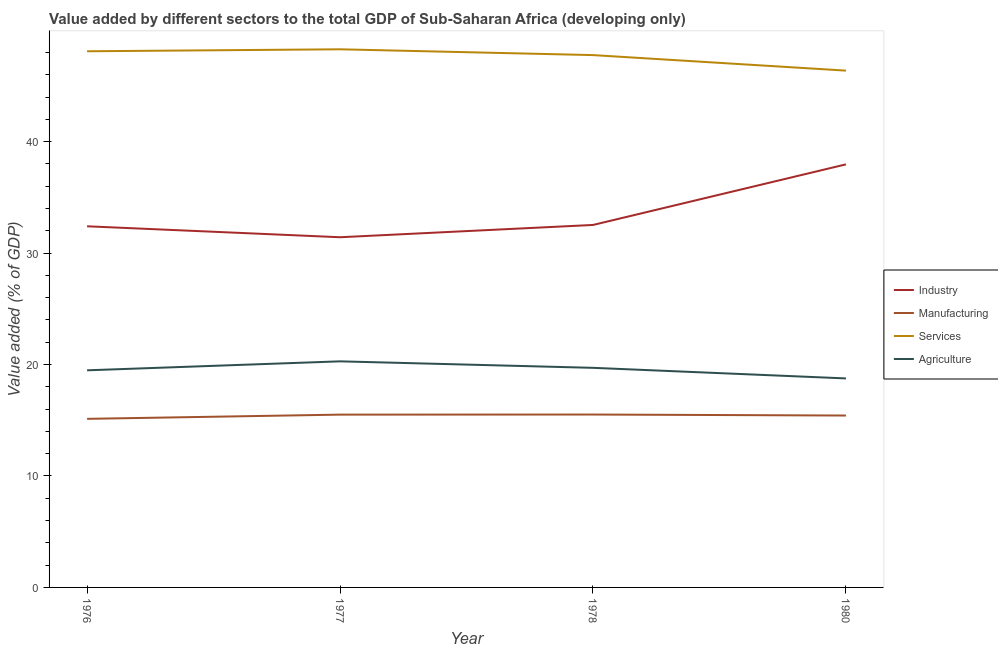How many different coloured lines are there?
Keep it short and to the point. 4. Is the number of lines equal to the number of legend labels?
Provide a succinct answer. Yes. What is the value added by industrial sector in 1980?
Keep it short and to the point. 37.96. Across all years, what is the maximum value added by agricultural sector?
Your response must be concise. 20.29. Across all years, what is the minimum value added by manufacturing sector?
Your answer should be compact. 15.13. In which year was the value added by services sector minimum?
Your answer should be very brief. 1980. What is the total value added by industrial sector in the graph?
Provide a short and direct response. 134.32. What is the difference between the value added by agricultural sector in 1976 and that in 1980?
Your response must be concise. 0.73. What is the difference between the value added by industrial sector in 1980 and the value added by agricultural sector in 1976?
Your answer should be compact. 18.48. What is the average value added by services sector per year?
Offer a terse response. 47.64. In the year 1980, what is the difference between the value added by services sector and value added by agricultural sector?
Give a very brief answer. 27.62. What is the ratio of the value added by agricultural sector in 1976 to that in 1977?
Make the answer very short. 0.96. Is the value added by agricultural sector in 1977 less than that in 1978?
Make the answer very short. No. What is the difference between the highest and the second highest value added by services sector?
Offer a very short reply. 0.18. What is the difference between the highest and the lowest value added by agricultural sector?
Offer a terse response. 1.53. Is it the case that in every year, the sum of the value added by services sector and value added by agricultural sector is greater than the sum of value added by industrial sector and value added by manufacturing sector?
Provide a short and direct response. Yes. Does the value added by agricultural sector monotonically increase over the years?
Keep it short and to the point. No. Is the value added by services sector strictly less than the value added by manufacturing sector over the years?
Your answer should be very brief. No. How many years are there in the graph?
Provide a succinct answer. 4. Are the values on the major ticks of Y-axis written in scientific E-notation?
Give a very brief answer. No. How many legend labels are there?
Ensure brevity in your answer.  4. How are the legend labels stacked?
Your answer should be very brief. Vertical. What is the title of the graph?
Keep it short and to the point. Value added by different sectors to the total GDP of Sub-Saharan Africa (developing only). What is the label or title of the X-axis?
Your answer should be compact. Year. What is the label or title of the Y-axis?
Provide a succinct answer. Value added (% of GDP). What is the Value added (% of GDP) in Industry in 1976?
Make the answer very short. 32.41. What is the Value added (% of GDP) in Manufacturing in 1976?
Make the answer very short. 15.13. What is the Value added (% of GDP) in Services in 1976?
Your response must be concise. 48.11. What is the Value added (% of GDP) of Agriculture in 1976?
Your response must be concise. 19.48. What is the Value added (% of GDP) of Industry in 1977?
Offer a terse response. 31.42. What is the Value added (% of GDP) of Manufacturing in 1977?
Give a very brief answer. 15.51. What is the Value added (% of GDP) in Services in 1977?
Give a very brief answer. 48.29. What is the Value added (% of GDP) in Agriculture in 1977?
Ensure brevity in your answer.  20.29. What is the Value added (% of GDP) in Industry in 1978?
Your answer should be very brief. 32.53. What is the Value added (% of GDP) of Manufacturing in 1978?
Make the answer very short. 15.51. What is the Value added (% of GDP) of Services in 1978?
Ensure brevity in your answer.  47.77. What is the Value added (% of GDP) of Agriculture in 1978?
Offer a terse response. 19.71. What is the Value added (% of GDP) of Industry in 1980?
Give a very brief answer. 37.96. What is the Value added (% of GDP) in Manufacturing in 1980?
Make the answer very short. 15.42. What is the Value added (% of GDP) in Services in 1980?
Make the answer very short. 46.38. What is the Value added (% of GDP) in Agriculture in 1980?
Your answer should be compact. 18.75. Across all years, what is the maximum Value added (% of GDP) in Industry?
Your response must be concise. 37.96. Across all years, what is the maximum Value added (% of GDP) in Manufacturing?
Give a very brief answer. 15.51. Across all years, what is the maximum Value added (% of GDP) of Services?
Keep it short and to the point. 48.29. Across all years, what is the maximum Value added (% of GDP) in Agriculture?
Make the answer very short. 20.29. Across all years, what is the minimum Value added (% of GDP) in Industry?
Offer a terse response. 31.42. Across all years, what is the minimum Value added (% of GDP) of Manufacturing?
Keep it short and to the point. 15.13. Across all years, what is the minimum Value added (% of GDP) of Services?
Offer a very short reply. 46.38. Across all years, what is the minimum Value added (% of GDP) of Agriculture?
Provide a short and direct response. 18.75. What is the total Value added (% of GDP) in Industry in the graph?
Provide a short and direct response. 134.32. What is the total Value added (% of GDP) of Manufacturing in the graph?
Give a very brief answer. 61.57. What is the total Value added (% of GDP) in Services in the graph?
Provide a short and direct response. 190.54. What is the total Value added (% of GDP) of Agriculture in the graph?
Keep it short and to the point. 78.23. What is the difference between the Value added (% of GDP) in Industry in 1976 and that in 1977?
Make the answer very short. 0.98. What is the difference between the Value added (% of GDP) of Manufacturing in 1976 and that in 1977?
Give a very brief answer. -0.38. What is the difference between the Value added (% of GDP) of Services in 1976 and that in 1977?
Ensure brevity in your answer.  -0.18. What is the difference between the Value added (% of GDP) of Agriculture in 1976 and that in 1977?
Offer a terse response. -0.81. What is the difference between the Value added (% of GDP) in Industry in 1976 and that in 1978?
Keep it short and to the point. -0.12. What is the difference between the Value added (% of GDP) of Manufacturing in 1976 and that in 1978?
Provide a short and direct response. -0.39. What is the difference between the Value added (% of GDP) in Services in 1976 and that in 1978?
Give a very brief answer. 0.34. What is the difference between the Value added (% of GDP) in Agriculture in 1976 and that in 1978?
Your answer should be very brief. -0.22. What is the difference between the Value added (% of GDP) of Industry in 1976 and that in 1980?
Your answer should be very brief. -5.56. What is the difference between the Value added (% of GDP) in Manufacturing in 1976 and that in 1980?
Keep it short and to the point. -0.3. What is the difference between the Value added (% of GDP) in Services in 1976 and that in 1980?
Provide a short and direct response. 1.74. What is the difference between the Value added (% of GDP) in Agriculture in 1976 and that in 1980?
Offer a terse response. 0.73. What is the difference between the Value added (% of GDP) in Industry in 1977 and that in 1978?
Make the answer very short. -1.1. What is the difference between the Value added (% of GDP) of Manufacturing in 1977 and that in 1978?
Give a very brief answer. -0.01. What is the difference between the Value added (% of GDP) in Services in 1977 and that in 1978?
Give a very brief answer. 0.52. What is the difference between the Value added (% of GDP) in Agriculture in 1977 and that in 1978?
Provide a short and direct response. 0.58. What is the difference between the Value added (% of GDP) of Industry in 1977 and that in 1980?
Your answer should be very brief. -6.54. What is the difference between the Value added (% of GDP) in Manufacturing in 1977 and that in 1980?
Your response must be concise. 0.08. What is the difference between the Value added (% of GDP) of Services in 1977 and that in 1980?
Your answer should be compact. 1.91. What is the difference between the Value added (% of GDP) in Agriculture in 1977 and that in 1980?
Provide a short and direct response. 1.53. What is the difference between the Value added (% of GDP) of Industry in 1978 and that in 1980?
Ensure brevity in your answer.  -5.44. What is the difference between the Value added (% of GDP) in Manufacturing in 1978 and that in 1980?
Ensure brevity in your answer.  0.09. What is the difference between the Value added (% of GDP) of Services in 1978 and that in 1980?
Keep it short and to the point. 1.39. What is the difference between the Value added (% of GDP) of Agriculture in 1978 and that in 1980?
Your response must be concise. 0.95. What is the difference between the Value added (% of GDP) in Industry in 1976 and the Value added (% of GDP) in Manufacturing in 1977?
Offer a very short reply. 16.9. What is the difference between the Value added (% of GDP) in Industry in 1976 and the Value added (% of GDP) in Services in 1977?
Make the answer very short. -15.88. What is the difference between the Value added (% of GDP) in Industry in 1976 and the Value added (% of GDP) in Agriculture in 1977?
Ensure brevity in your answer.  12.12. What is the difference between the Value added (% of GDP) in Manufacturing in 1976 and the Value added (% of GDP) in Services in 1977?
Keep it short and to the point. -33.16. What is the difference between the Value added (% of GDP) of Manufacturing in 1976 and the Value added (% of GDP) of Agriculture in 1977?
Your response must be concise. -5.16. What is the difference between the Value added (% of GDP) of Services in 1976 and the Value added (% of GDP) of Agriculture in 1977?
Your response must be concise. 27.82. What is the difference between the Value added (% of GDP) in Industry in 1976 and the Value added (% of GDP) in Manufacturing in 1978?
Make the answer very short. 16.89. What is the difference between the Value added (% of GDP) of Industry in 1976 and the Value added (% of GDP) of Services in 1978?
Your answer should be compact. -15.36. What is the difference between the Value added (% of GDP) of Industry in 1976 and the Value added (% of GDP) of Agriculture in 1978?
Your answer should be very brief. 12.7. What is the difference between the Value added (% of GDP) of Manufacturing in 1976 and the Value added (% of GDP) of Services in 1978?
Your response must be concise. -32.64. What is the difference between the Value added (% of GDP) in Manufacturing in 1976 and the Value added (% of GDP) in Agriculture in 1978?
Make the answer very short. -4.58. What is the difference between the Value added (% of GDP) in Services in 1976 and the Value added (% of GDP) in Agriculture in 1978?
Provide a succinct answer. 28.41. What is the difference between the Value added (% of GDP) of Industry in 1976 and the Value added (% of GDP) of Manufacturing in 1980?
Offer a very short reply. 16.98. What is the difference between the Value added (% of GDP) in Industry in 1976 and the Value added (% of GDP) in Services in 1980?
Your response must be concise. -13.97. What is the difference between the Value added (% of GDP) in Industry in 1976 and the Value added (% of GDP) in Agriculture in 1980?
Your response must be concise. 13.65. What is the difference between the Value added (% of GDP) of Manufacturing in 1976 and the Value added (% of GDP) of Services in 1980?
Keep it short and to the point. -31.25. What is the difference between the Value added (% of GDP) of Manufacturing in 1976 and the Value added (% of GDP) of Agriculture in 1980?
Make the answer very short. -3.63. What is the difference between the Value added (% of GDP) in Services in 1976 and the Value added (% of GDP) in Agriculture in 1980?
Provide a succinct answer. 29.36. What is the difference between the Value added (% of GDP) of Industry in 1977 and the Value added (% of GDP) of Manufacturing in 1978?
Provide a succinct answer. 15.91. What is the difference between the Value added (% of GDP) in Industry in 1977 and the Value added (% of GDP) in Services in 1978?
Your answer should be compact. -16.35. What is the difference between the Value added (% of GDP) of Industry in 1977 and the Value added (% of GDP) of Agriculture in 1978?
Ensure brevity in your answer.  11.72. What is the difference between the Value added (% of GDP) in Manufacturing in 1977 and the Value added (% of GDP) in Services in 1978?
Offer a terse response. -32.26. What is the difference between the Value added (% of GDP) of Manufacturing in 1977 and the Value added (% of GDP) of Agriculture in 1978?
Ensure brevity in your answer.  -4.2. What is the difference between the Value added (% of GDP) in Services in 1977 and the Value added (% of GDP) in Agriculture in 1978?
Your response must be concise. 28.58. What is the difference between the Value added (% of GDP) of Industry in 1977 and the Value added (% of GDP) of Manufacturing in 1980?
Offer a terse response. 16. What is the difference between the Value added (% of GDP) of Industry in 1977 and the Value added (% of GDP) of Services in 1980?
Keep it short and to the point. -14.95. What is the difference between the Value added (% of GDP) of Industry in 1977 and the Value added (% of GDP) of Agriculture in 1980?
Make the answer very short. 12.67. What is the difference between the Value added (% of GDP) in Manufacturing in 1977 and the Value added (% of GDP) in Services in 1980?
Your answer should be compact. -30.87. What is the difference between the Value added (% of GDP) in Manufacturing in 1977 and the Value added (% of GDP) in Agriculture in 1980?
Keep it short and to the point. -3.25. What is the difference between the Value added (% of GDP) in Services in 1977 and the Value added (% of GDP) in Agriculture in 1980?
Provide a succinct answer. 29.53. What is the difference between the Value added (% of GDP) in Industry in 1978 and the Value added (% of GDP) in Manufacturing in 1980?
Make the answer very short. 17.1. What is the difference between the Value added (% of GDP) in Industry in 1978 and the Value added (% of GDP) in Services in 1980?
Ensure brevity in your answer.  -13.85. What is the difference between the Value added (% of GDP) in Industry in 1978 and the Value added (% of GDP) in Agriculture in 1980?
Your answer should be very brief. 13.77. What is the difference between the Value added (% of GDP) of Manufacturing in 1978 and the Value added (% of GDP) of Services in 1980?
Give a very brief answer. -30.86. What is the difference between the Value added (% of GDP) of Manufacturing in 1978 and the Value added (% of GDP) of Agriculture in 1980?
Offer a terse response. -3.24. What is the difference between the Value added (% of GDP) in Services in 1978 and the Value added (% of GDP) in Agriculture in 1980?
Your response must be concise. 29.01. What is the average Value added (% of GDP) in Industry per year?
Your answer should be compact. 33.58. What is the average Value added (% of GDP) of Manufacturing per year?
Provide a short and direct response. 15.39. What is the average Value added (% of GDP) of Services per year?
Give a very brief answer. 47.64. What is the average Value added (% of GDP) of Agriculture per year?
Provide a short and direct response. 19.56. In the year 1976, what is the difference between the Value added (% of GDP) of Industry and Value added (% of GDP) of Manufacturing?
Your answer should be compact. 17.28. In the year 1976, what is the difference between the Value added (% of GDP) in Industry and Value added (% of GDP) in Services?
Keep it short and to the point. -15.71. In the year 1976, what is the difference between the Value added (% of GDP) of Industry and Value added (% of GDP) of Agriculture?
Keep it short and to the point. 12.92. In the year 1976, what is the difference between the Value added (% of GDP) in Manufacturing and Value added (% of GDP) in Services?
Offer a very short reply. -32.98. In the year 1976, what is the difference between the Value added (% of GDP) of Manufacturing and Value added (% of GDP) of Agriculture?
Ensure brevity in your answer.  -4.35. In the year 1976, what is the difference between the Value added (% of GDP) of Services and Value added (% of GDP) of Agriculture?
Keep it short and to the point. 28.63. In the year 1977, what is the difference between the Value added (% of GDP) of Industry and Value added (% of GDP) of Manufacturing?
Offer a very short reply. 15.92. In the year 1977, what is the difference between the Value added (% of GDP) of Industry and Value added (% of GDP) of Services?
Ensure brevity in your answer.  -16.86. In the year 1977, what is the difference between the Value added (% of GDP) in Industry and Value added (% of GDP) in Agriculture?
Offer a very short reply. 11.14. In the year 1977, what is the difference between the Value added (% of GDP) of Manufacturing and Value added (% of GDP) of Services?
Your answer should be very brief. -32.78. In the year 1977, what is the difference between the Value added (% of GDP) in Manufacturing and Value added (% of GDP) in Agriculture?
Your answer should be very brief. -4.78. In the year 1977, what is the difference between the Value added (% of GDP) in Services and Value added (% of GDP) in Agriculture?
Provide a succinct answer. 28. In the year 1978, what is the difference between the Value added (% of GDP) in Industry and Value added (% of GDP) in Manufacturing?
Ensure brevity in your answer.  17.01. In the year 1978, what is the difference between the Value added (% of GDP) of Industry and Value added (% of GDP) of Services?
Give a very brief answer. -15.24. In the year 1978, what is the difference between the Value added (% of GDP) of Industry and Value added (% of GDP) of Agriculture?
Your answer should be compact. 12.82. In the year 1978, what is the difference between the Value added (% of GDP) in Manufacturing and Value added (% of GDP) in Services?
Ensure brevity in your answer.  -32.26. In the year 1978, what is the difference between the Value added (% of GDP) of Manufacturing and Value added (% of GDP) of Agriculture?
Ensure brevity in your answer.  -4.19. In the year 1978, what is the difference between the Value added (% of GDP) of Services and Value added (% of GDP) of Agriculture?
Provide a short and direct response. 28.06. In the year 1980, what is the difference between the Value added (% of GDP) in Industry and Value added (% of GDP) in Manufacturing?
Keep it short and to the point. 22.54. In the year 1980, what is the difference between the Value added (% of GDP) in Industry and Value added (% of GDP) in Services?
Your response must be concise. -8.41. In the year 1980, what is the difference between the Value added (% of GDP) of Industry and Value added (% of GDP) of Agriculture?
Ensure brevity in your answer.  19.21. In the year 1980, what is the difference between the Value added (% of GDP) in Manufacturing and Value added (% of GDP) in Services?
Your response must be concise. -30.95. In the year 1980, what is the difference between the Value added (% of GDP) in Manufacturing and Value added (% of GDP) in Agriculture?
Make the answer very short. -3.33. In the year 1980, what is the difference between the Value added (% of GDP) in Services and Value added (% of GDP) in Agriculture?
Ensure brevity in your answer.  27.62. What is the ratio of the Value added (% of GDP) in Industry in 1976 to that in 1977?
Offer a terse response. 1.03. What is the ratio of the Value added (% of GDP) of Manufacturing in 1976 to that in 1977?
Keep it short and to the point. 0.98. What is the ratio of the Value added (% of GDP) of Agriculture in 1976 to that in 1977?
Offer a terse response. 0.96. What is the ratio of the Value added (% of GDP) of Industry in 1976 to that in 1978?
Your answer should be very brief. 1. What is the ratio of the Value added (% of GDP) of Manufacturing in 1976 to that in 1978?
Provide a succinct answer. 0.98. What is the ratio of the Value added (% of GDP) of Services in 1976 to that in 1978?
Offer a very short reply. 1.01. What is the ratio of the Value added (% of GDP) of Agriculture in 1976 to that in 1978?
Keep it short and to the point. 0.99. What is the ratio of the Value added (% of GDP) in Industry in 1976 to that in 1980?
Offer a terse response. 0.85. What is the ratio of the Value added (% of GDP) of Manufacturing in 1976 to that in 1980?
Provide a succinct answer. 0.98. What is the ratio of the Value added (% of GDP) in Services in 1976 to that in 1980?
Provide a short and direct response. 1.04. What is the ratio of the Value added (% of GDP) of Agriculture in 1976 to that in 1980?
Offer a very short reply. 1.04. What is the ratio of the Value added (% of GDP) in Industry in 1977 to that in 1978?
Ensure brevity in your answer.  0.97. What is the ratio of the Value added (% of GDP) of Manufacturing in 1977 to that in 1978?
Give a very brief answer. 1. What is the ratio of the Value added (% of GDP) of Services in 1977 to that in 1978?
Your response must be concise. 1.01. What is the ratio of the Value added (% of GDP) in Agriculture in 1977 to that in 1978?
Provide a succinct answer. 1.03. What is the ratio of the Value added (% of GDP) in Industry in 1977 to that in 1980?
Ensure brevity in your answer.  0.83. What is the ratio of the Value added (% of GDP) in Services in 1977 to that in 1980?
Offer a very short reply. 1.04. What is the ratio of the Value added (% of GDP) of Agriculture in 1977 to that in 1980?
Keep it short and to the point. 1.08. What is the ratio of the Value added (% of GDP) of Industry in 1978 to that in 1980?
Offer a terse response. 0.86. What is the ratio of the Value added (% of GDP) of Services in 1978 to that in 1980?
Give a very brief answer. 1.03. What is the ratio of the Value added (% of GDP) of Agriculture in 1978 to that in 1980?
Provide a succinct answer. 1.05. What is the difference between the highest and the second highest Value added (% of GDP) in Industry?
Give a very brief answer. 5.44. What is the difference between the highest and the second highest Value added (% of GDP) in Manufacturing?
Keep it short and to the point. 0.01. What is the difference between the highest and the second highest Value added (% of GDP) of Services?
Give a very brief answer. 0.18. What is the difference between the highest and the second highest Value added (% of GDP) in Agriculture?
Keep it short and to the point. 0.58. What is the difference between the highest and the lowest Value added (% of GDP) of Industry?
Ensure brevity in your answer.  6.54. What is the difference between the highest and the lowest Value added (% of GDP) of Manufacturing?
Your answer should be very brief. 0.39. What is the difference between the highest and the lowest Value added (% of GDP) in Services?
Provide a succinct answer. 1.91. What is the difference between the highest and the lowest Value added (% of GDP) in Agriculture?
Offer a very short reply. 1.53. 